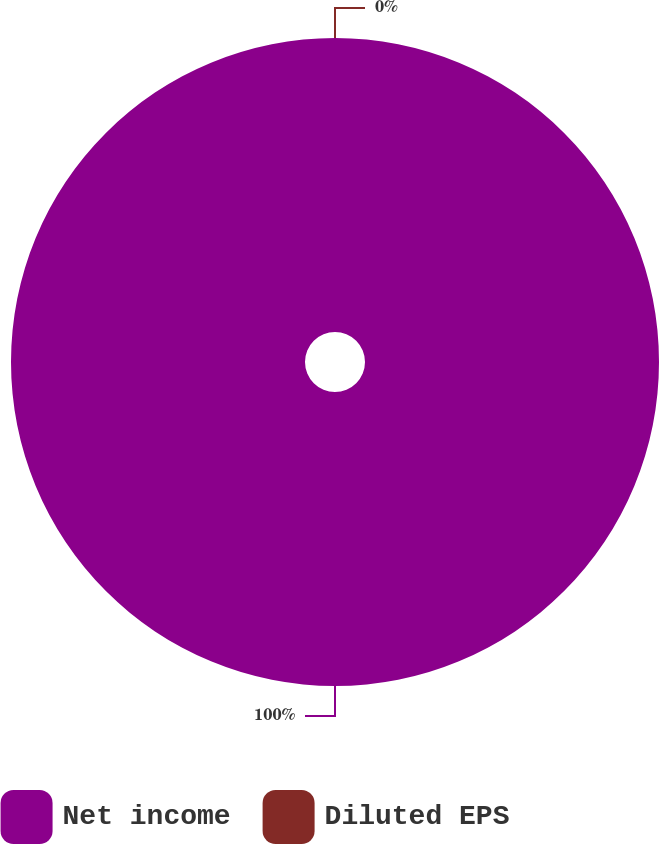<chart> <loc_0><loc_0><loc_500><loc_500><pie_chart><fcel>Net income<fcel>Diluted EPS<nl><fcel>100.0%<fcel>0.0%<nl></chart> 